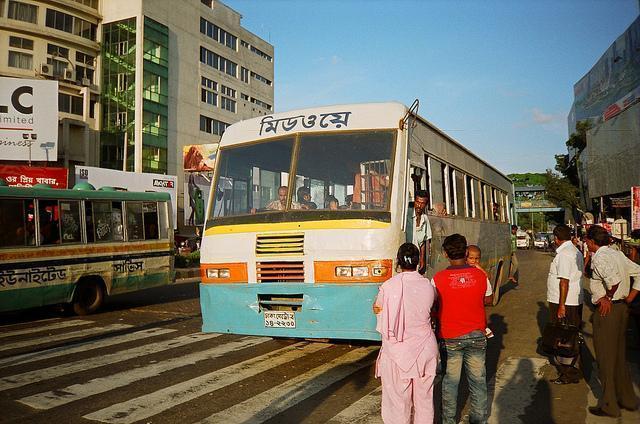What is the man with mustache about to do?
Make your selection and explain in format: 'Answer: answer
Rationale: rationale.'
Options: Board bus, sightseeing, block people, get off. Answer: get off.
Rationale: He is leaning out the door as the bus is about to stop 